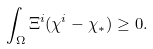Convert formula to latex. <formula><loc_0><loc_0><loc_500><loc_500>\int _ { \Omega } \Xi ^ { i } ( \chi ^ { i } - \chi _ { \ast } ) \geq 0 .</formula> 